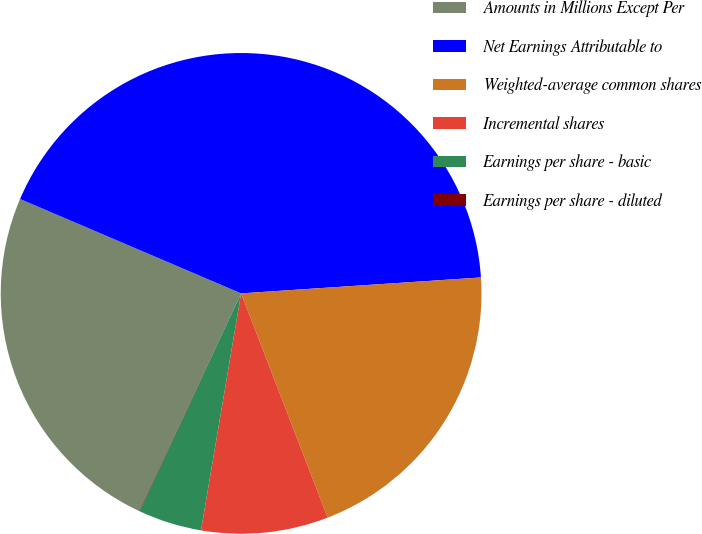<chart> <loc_0><loc_0><loc_500><loc_500><pie_chart><fcel>Amounts in Millions Except Per<fcel>Net Earnings Attributable to<fcel>Weighted-average common shares<fcel>Incremental shares<fcel>Earnings per share - basic<fcel>Earnings per share - diluted<nl><fcel>24.45%<fcel>42.53%<fcel>20.2%<fcel>8.53%<fcel>4.28%<fcel>0.03%<nl></chart> 